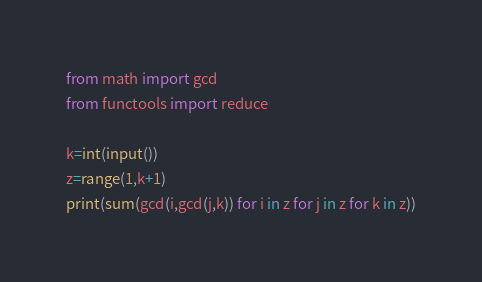<code> <loc_0><loc_0><loc_500><loc_500><_Python_>from math import gcd
from functools import reduce
 
k=int(input())
z=range(1,k+1)
print(sum(gcd(i,gcd(j,k)) for i in z for j in z for k in z))
</code> 